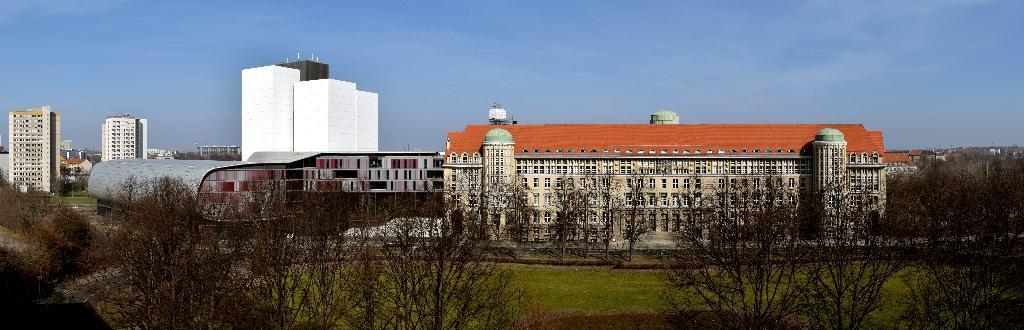What type of location is depicted in the image? The image depicts a city. What structures can be seen in the city? There are buildings in the image. Are there any natural elements present in the city? Yes, there are trees in the image. What is visible at the top of the image? The sky is visible at the top of the image. What type of ground surface is present at the bottom of the image? Grass is present at the bottom of the image. How many needles are sticking out of the buildings in the image? There are no needles present in the image; it features a city with buildings, trees, sky, and grass. 